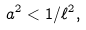<formula> <loc_0><loc_0><loc_500><loc_500>a ^ { 2 } < 1 / \ell ^ { 2 } ,</formula> 